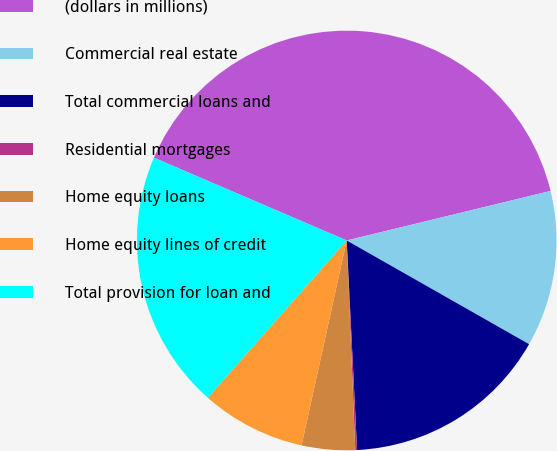Convert chart to OTSL. <chart><loc_0><loc_0><loc_500><loc_500><pie_chart><fcel>(dollars in millions)<fcel>Commercial real estate<fcel>Total commercial loans and<fcel>Residential mortgages<fcel>Home equity loans<fcel>Home equity lines of credit<fcel>Total provision for loan and<nl><fcel>39.75%<fcel>12.02%<fcel>15.98%<fcel>0.14%<fcel>4.1%<fcel>8.06%<fcel>19.94%<nl></chart> 